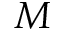<formula> <loc_0><loc_0><loc_500><loc_500>M</formula> 